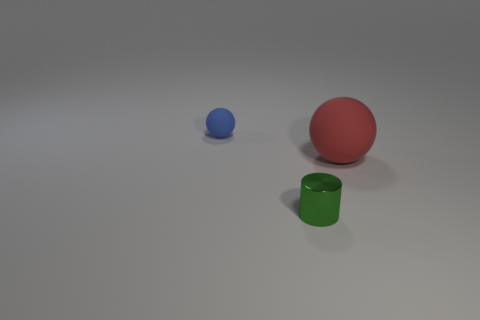Add 2 small gray metallic balls. How many objects exist? 5 Subtract all spheres. How many objects are left? 1 Add 2 green objects. How many green objects exist? 3 Subtract 0 red cubes. How many objects are left? 3 Subtract all blocks. Subtract all tiny green metallic cylinders. How many objects are left? 2 Add 3 large red rubber objects. How many large red rubber objects are left? 4 